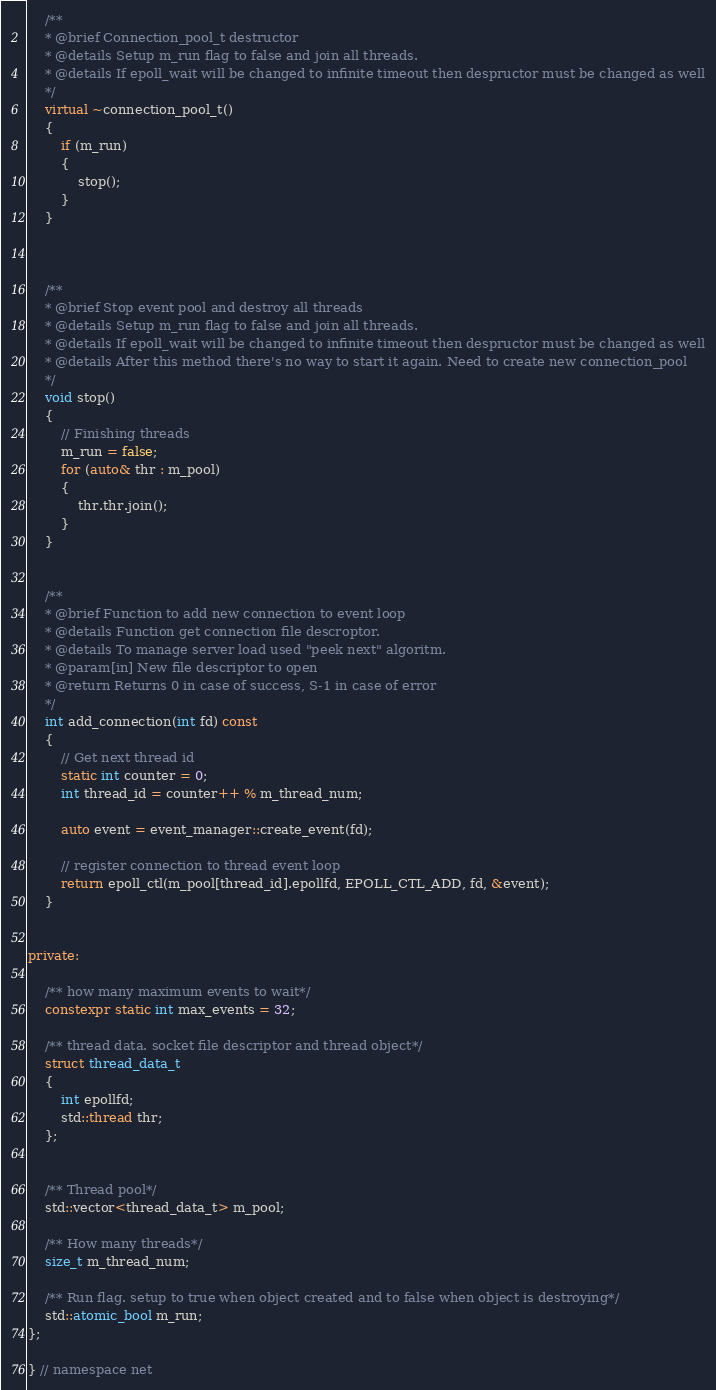<code> <loc_0><loc_0><loc_500><loc_500><_C++_>


    /**
    * @brief Connection_pool_t destructor
    * @details Setup m_run flag to false and join all threads.
    * @details If epoll_wait will be changed to infinite timeout then despructor must be changed as well
    */
    virtual ~connection_pool_t()
    {
        if (m_run)
        {
            stop();
        }
    }



    /**
    * @brief Stop event pool and destroy all threads
    * @details Setup m_run flag to false and join all threads.
    * @details If epoll_wait will be changed to infinite timeout then despructor must be changed as well
    * @details After this method there's no way to start it again. Need to create new connection_pool
    */
    void stop()
    {
        // Finishing threads
        m_run = false;
        for (auto& thr : m_pool)
        {
            thr.thr.join();
        }
    }


    /**
    * @brief Function to add new connection to event loop
    * @details Function get connection file descroptor.
    * @details To manage server load used "peek next" algoritm.
    * @param[in] New file descriptor to open
    * @return Returns 0 in case of success, S-1 in case of error
    */
    int add_connection(int fd) const
    {
        // Get next thread id
        static int counter = 0;
        int thread_id = counter++ % m_thread_num;

        auto event = event_manager::create_event(fd);

        // register connection to thread event loop
        return epoll_ctl(m_pool[thread_id].epollfd, EPOLL_CTL_ADD, fd, &event);
    }


private:

    /** how many maximum events to wait*/
    constexpr static int max_events = 32;

    /** thread data. socket file descriptor and thread object*/
    struct thread_data_t
    {
        int epollfd;
        std::thread thr;
    };


    /** Thread pool*/
    std::vector<thread_data_t> m_pool;

    /** How many threads*/
    size_t m_thread_num;

    /** Run flag. setup to true when object created and to false when object is destroying*/
    std::atomic_bool m_run;
};

} // namespace net
</code> 